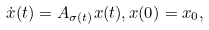<formula> <loc_0><loc_0><loc_500><loc_500>\dot { x } ( t ) & = A _ { \sigma ( t ) } x ( t ) , x ( 0 ) = x _ { 0 } ,</formula> 